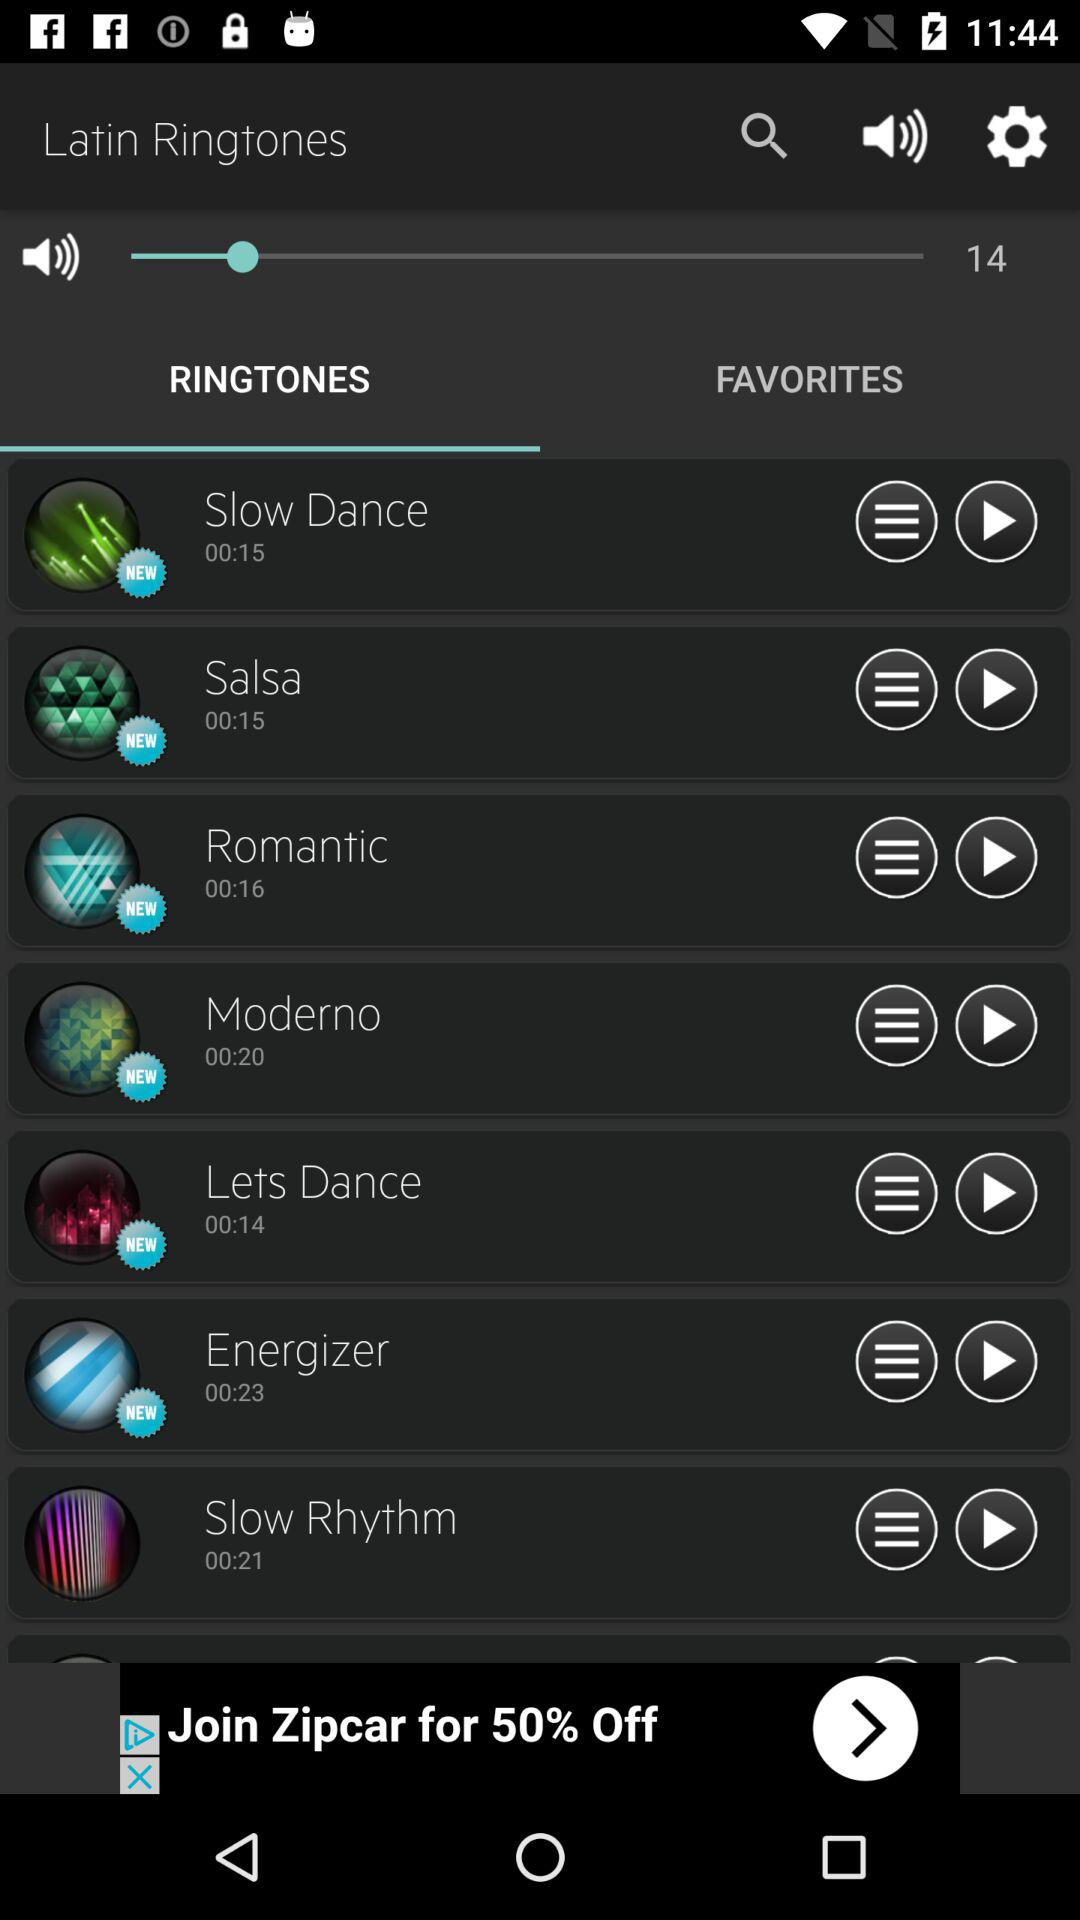What is the duration of "Slow Dance" ringtone? The duration is 15 seconds. 